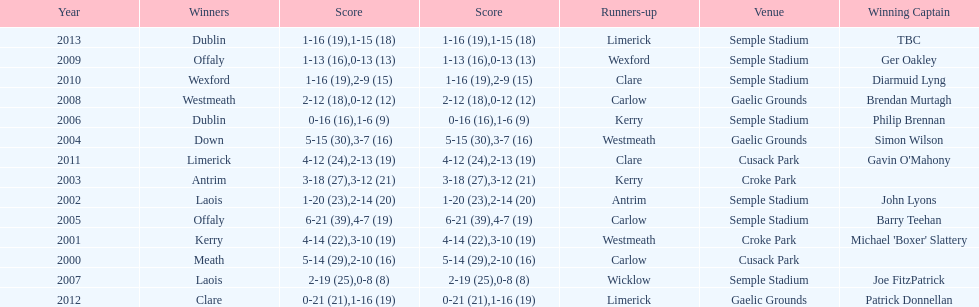How many times was carlow the runner-up? 3. 